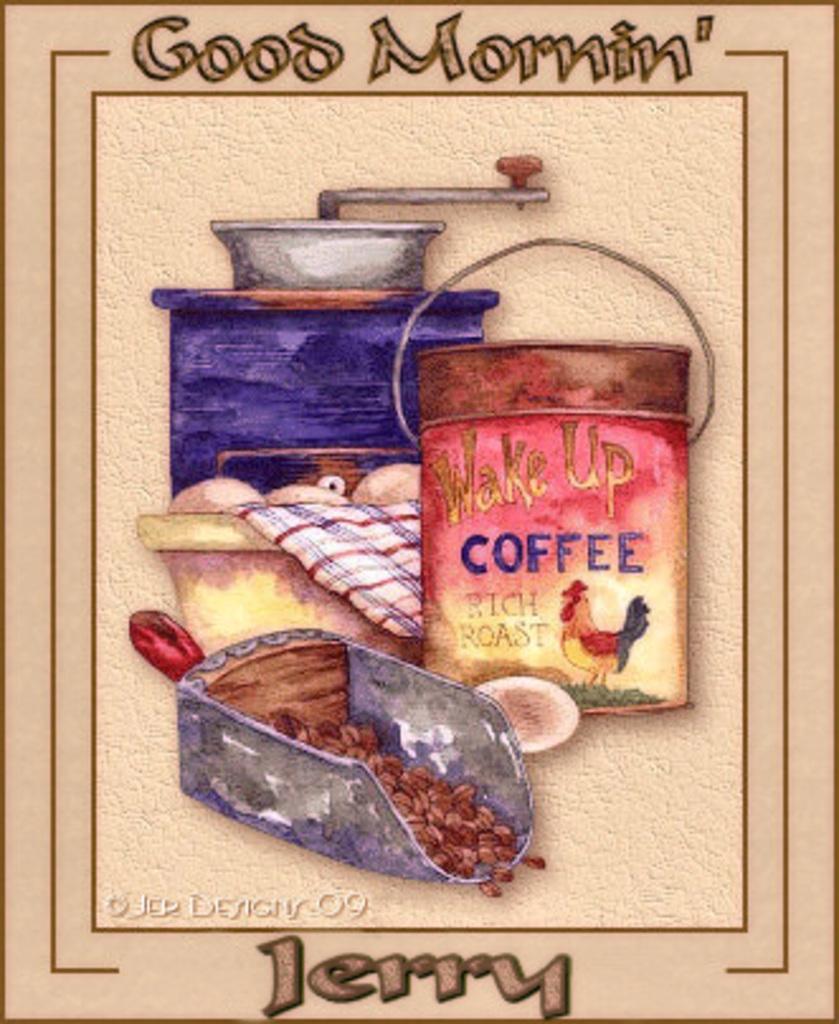Could you give a brief overview of what you see in this image? It is an edited image. In the center of the image there are some objects. At top and bottom of the image there is some text written on it. 